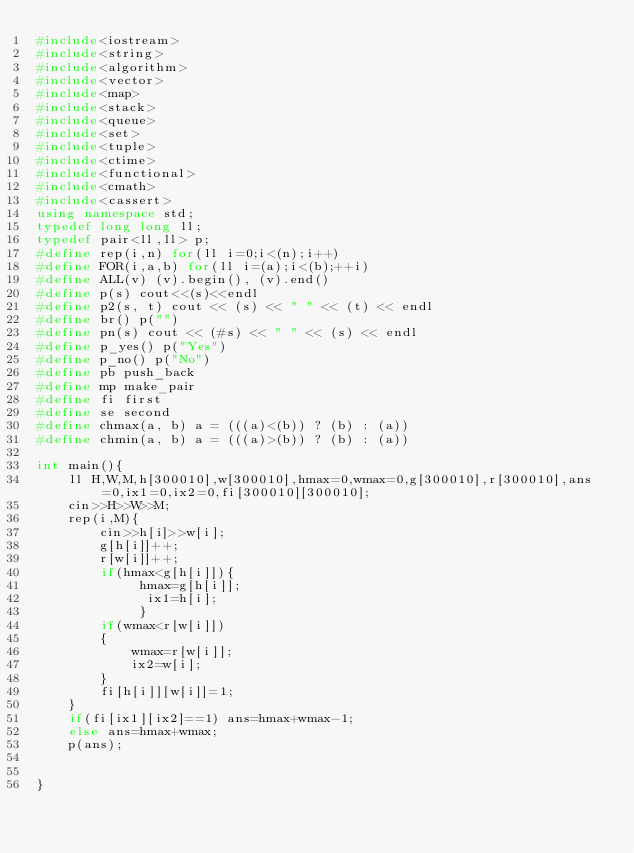<code> <loc_0><loc_0><loc_500><loc_500><_C++_>#include<iostream>
#include<string>
#include<algorithm>
#include<vector>
#include<map>
#include<stack>
#include<queue>
#include<set>
#include<tuple>
#include<ctime>
#include<functional>
#include<cmath>
#include<cassert>
using namespace std;
typedef long long ll;
typedef pair<ll,ll> p; 
#define rep(i,n) for(ll i=0;i<(n);i++)
#define FOR(i,a,b) for(ll i=(a);i<(b);++i)
#define ALL(v) (v).begin(), (v).end()
#define p(s) cout<<(s)<<endl
#define p2(s, t) cout << (s) << " " << (t) << endl
#define br() p("")
#define pn(s) cout << (#s) << " " << (s) << endl
#define p_yes() p("Yes")
#define p_no() p("No")
#define pb push_back
#define mp make_pair
#define fi first
#define se second
#define chmax(a, b) a = (((a)<(b)) ? (b) : (a))
#define chmin(a, b) a = (((a)>(b)) ? (b) : (a))

int main(){
    ll H,W,M,h[300010],w[300010],hmax=0,wmax=0,g[300010],r[300010],ans=0,ix1=0,ix2=0,fi[300010][300010];
    cin>>H>>W>>M;
    rep(i,M){
        cin>>h[i]>>w[i];
        g[h[i]]++;
        r[w[i]]++;
        if(hmax<g[h[i]]){
             hmax=g[h[i]];
              ix1=h[i];
             }
        if(wmax<r[w[i]]) 
        {
            wmax=r[w[i]];
            ix2=w[i];
        }
        fi[h[i]][w[i]]=1;
    }
    if(fi[ix1][ix2]==1) ans=hmax+wmax-1;
    else ans=hmax+wmax;
    p(ans);   
    

}</code> 